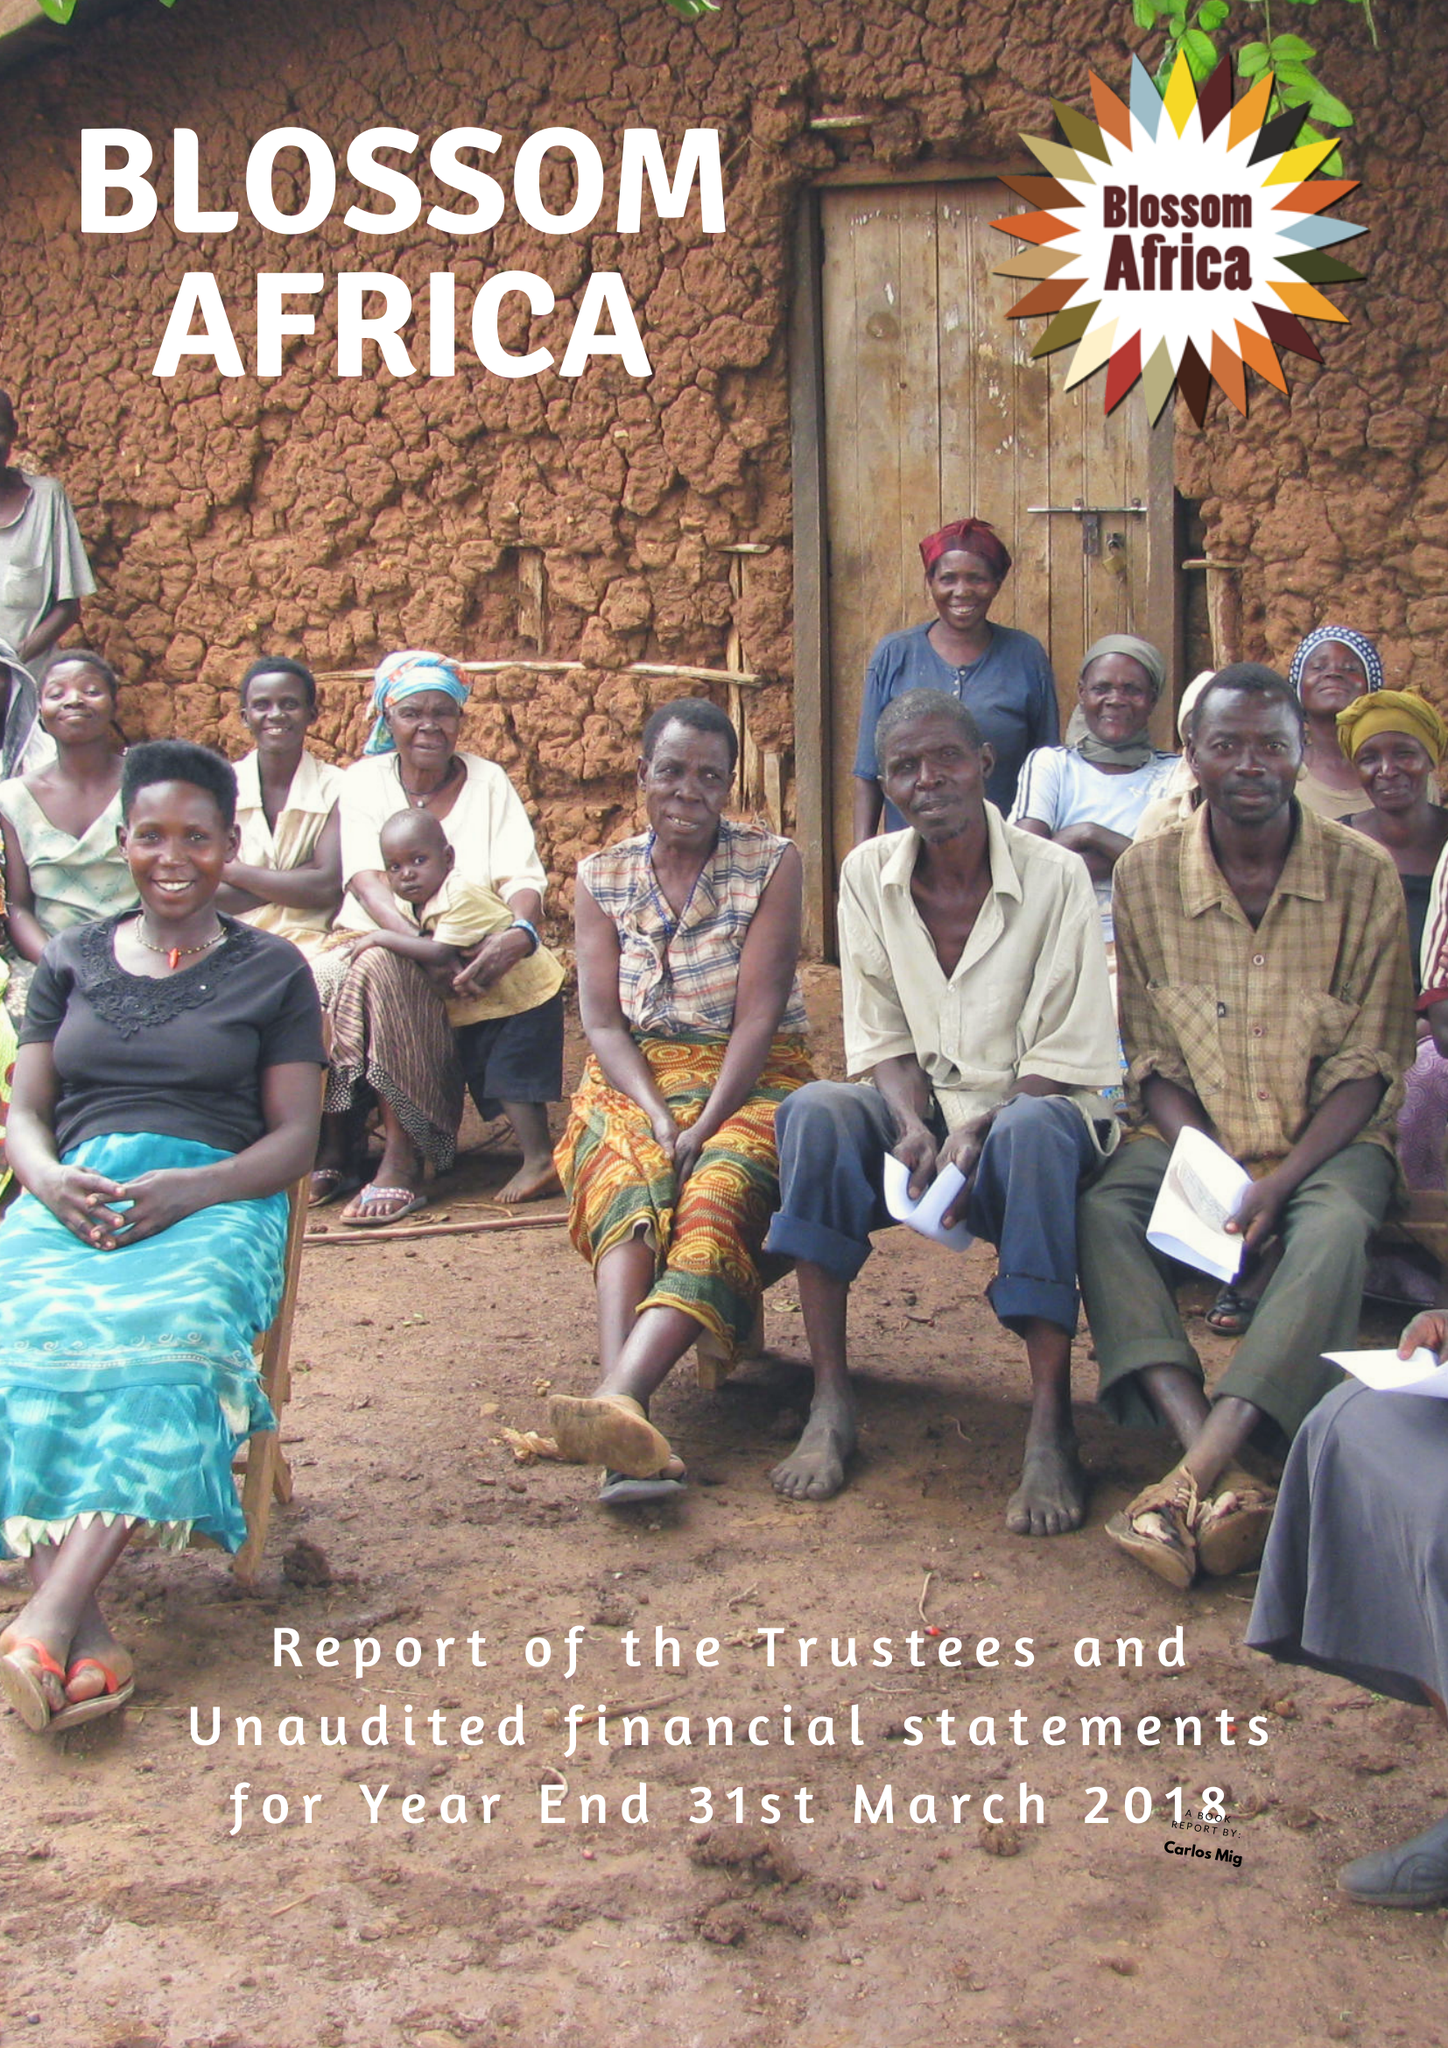What is the value for the charity_name?
Answer the question using a single word or phrase. Blossom Africa 